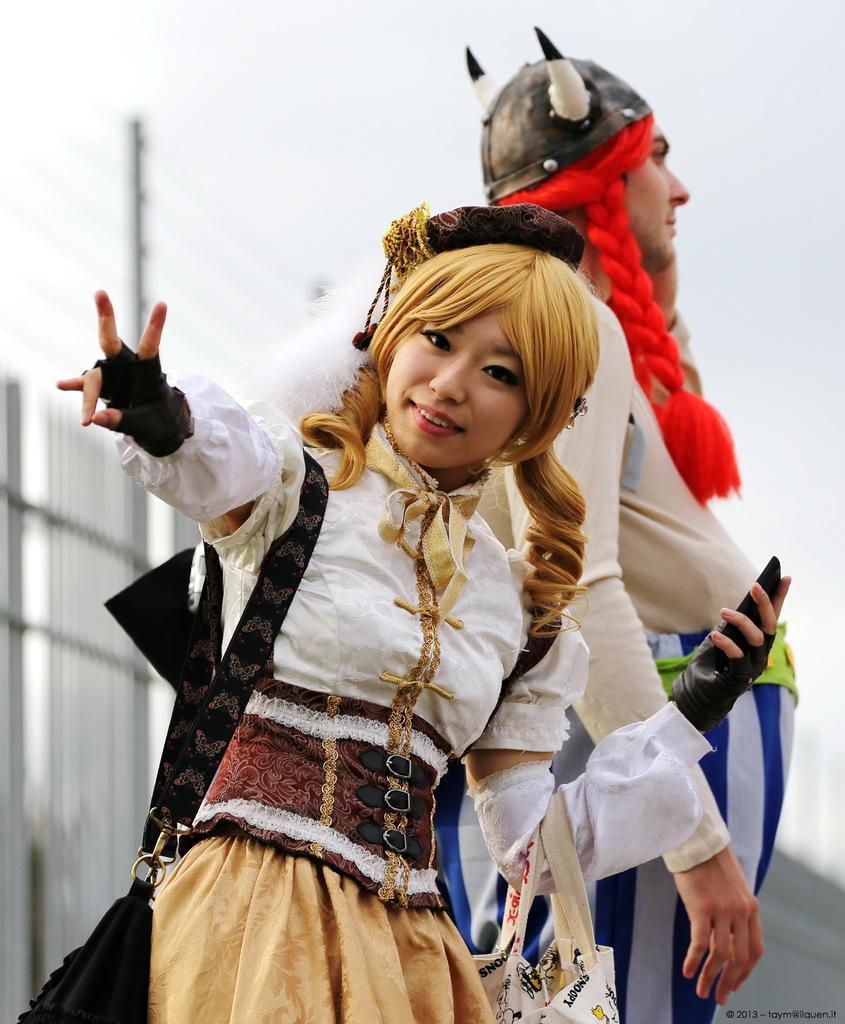How would you summarize this image in a sentence or two? In this image there are two persons standing, behind them there is a railing. In the background there is the sky and a pole. 